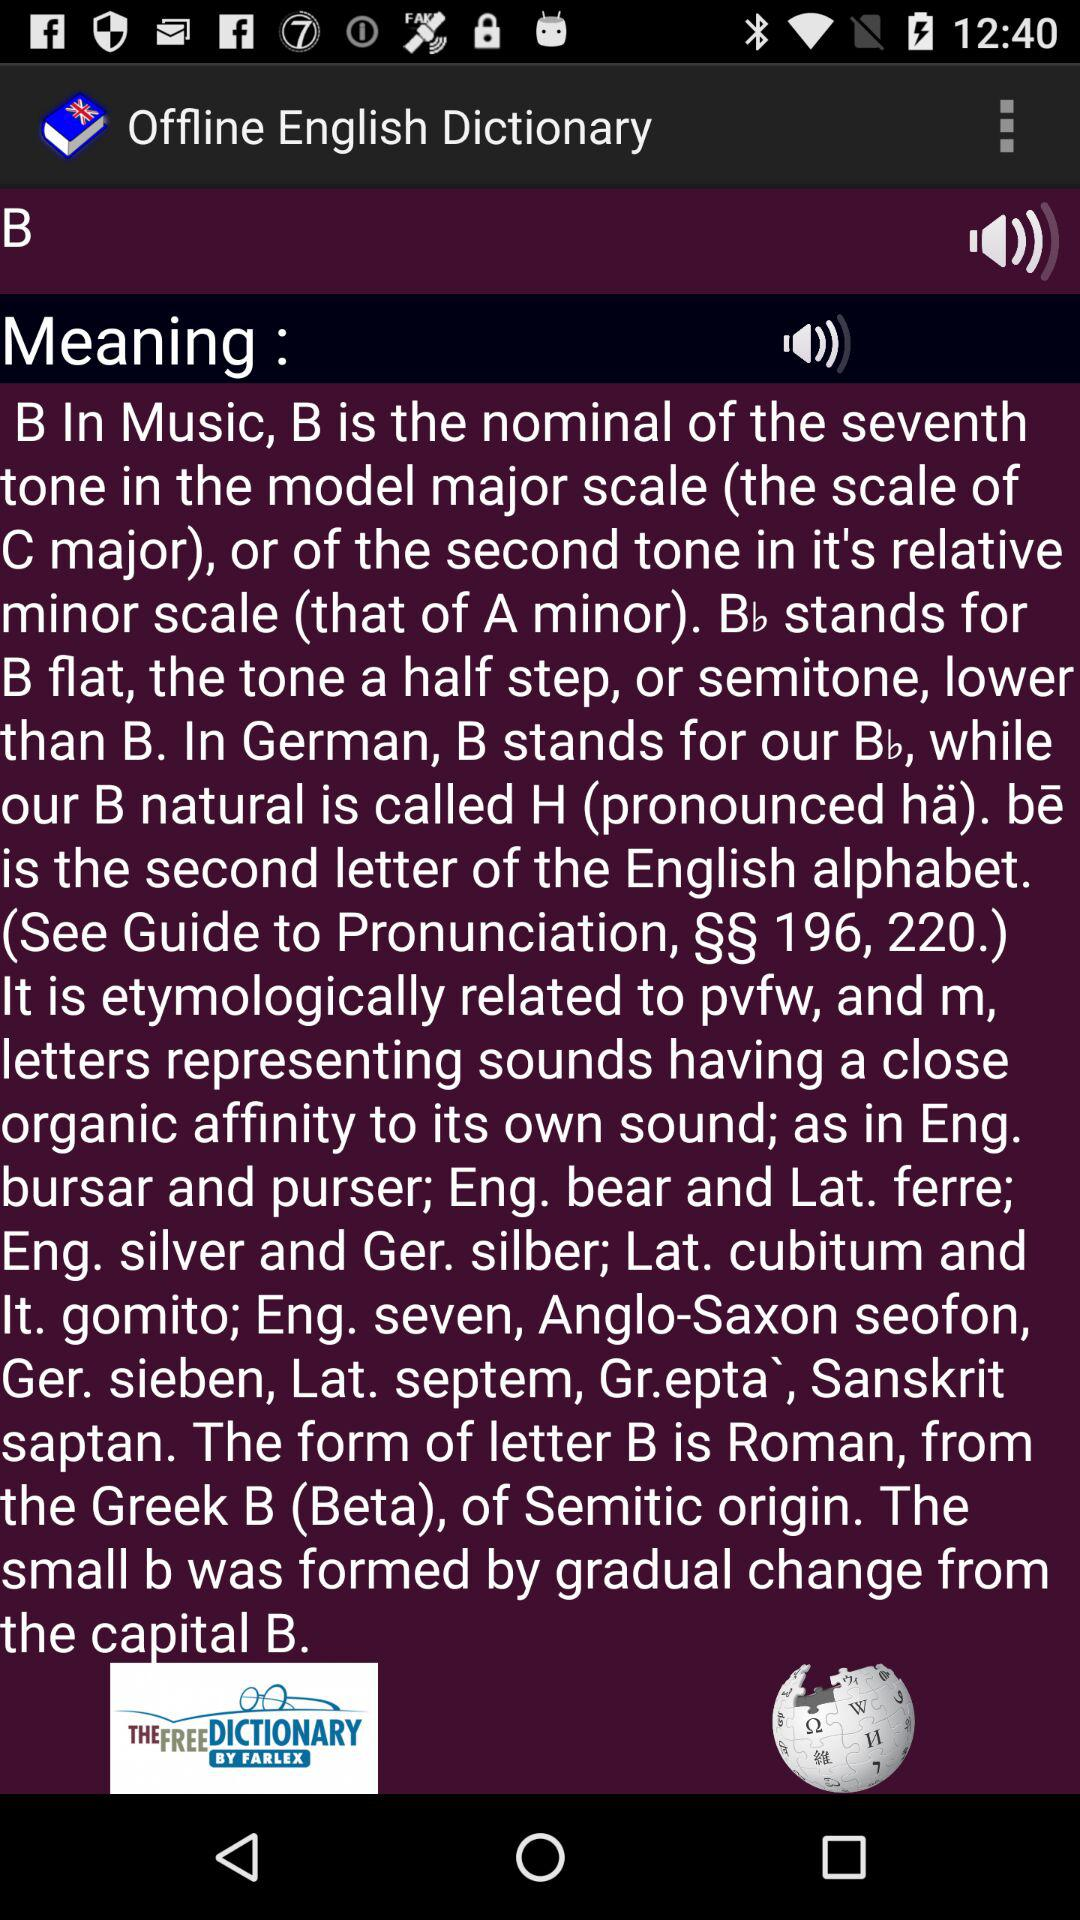What is the word whose meaning is shown? The word whose meaning is shown is "B". 